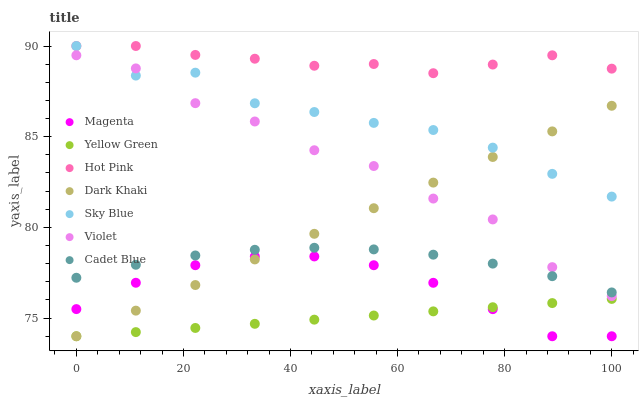Does Yellow Green have the minimum area under the curve?
Answer yes or no. Yes. Does Hot Pink have the maximum area under the curve?
Answer yes or no. Yes. Does Hot Pink have the minimum area under the curve?
Answer yes or no. No. Does Yellow Green have the maximum area under the curve?
Answer yes or no. No. Is Dark Khaki the smoothest?
Answer yes or no. Yes. Is Violet the roughest?
Answer yes or no. Yes. Is Yellow Green the smoothest?
Answer yes or no. No. Is Yellow Green the roughest?
Answer yes or no. No. Does Yellow Green have the lowest value?
Answer yes or no. Yes. Does Hot Pink have the lowest value?
Answer yes or no. No. Does Sky Blue have the highest value?
Answer yes or no. Yes. Does Yellow Green have the highest value?
Answer yes or no. No. Is Cadet Blue less than Hot Pink?
Answer yes or no. Yes. Is Hot Pink greater than Cadet Blue?
Answer yes or no. Yes. Does Magenta intersect Dark Khaki?
Answer yes or no. Yes. Is Magenta less than Dark Khaki?
Answer yes or no. No. Is Magenta greater than Dark Khaki?
Answer yes or no. No. Does Cadet Blue intersect Hot Pink?
Answer yes or no. No. 